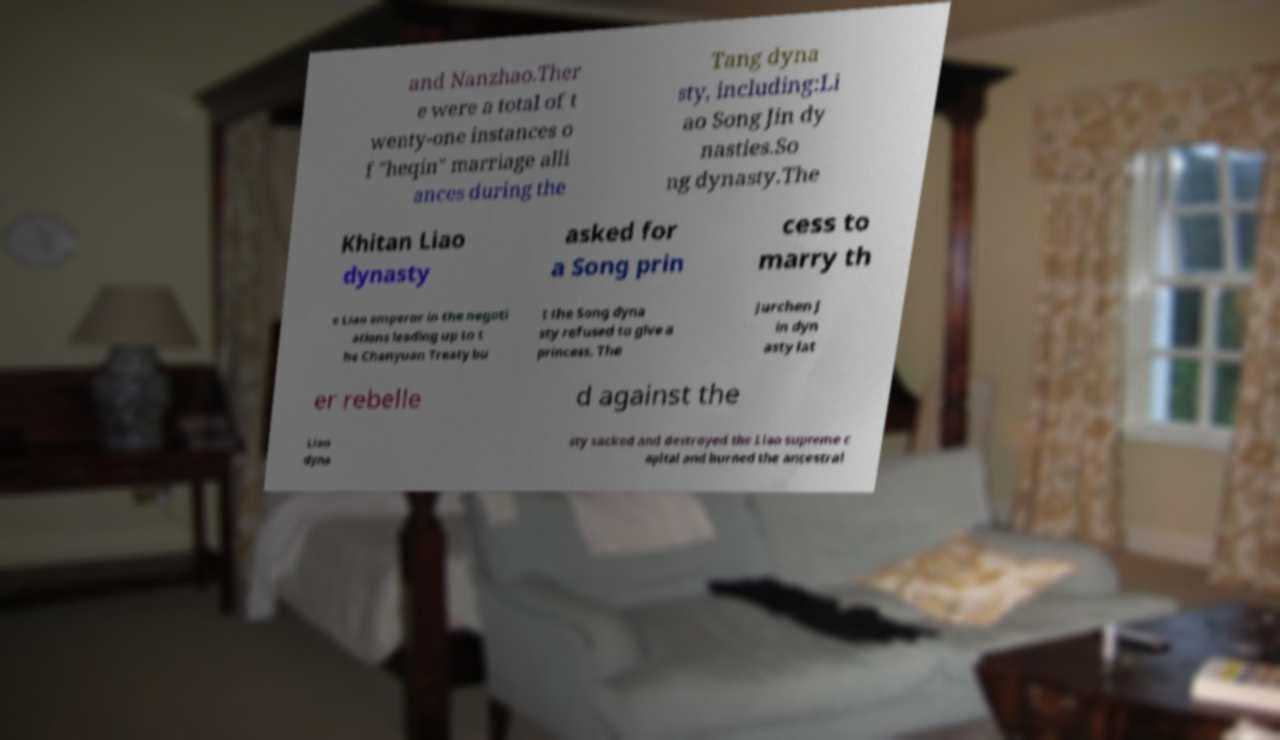Please identify and transcribe the text found in this image. and Nanzhao.Ther e were a total of t wenty-one instances o f "heqin" marriage alli ances during the Tang dyna sty, including:Li ao Song Jin dy nasties.So ng dynasty.The Khitan Liao dynasty asked for a Song prin cess to marry th e Liao emperor in the negoti ations leading up to t he Chanyuan Treaty bu t the Song dyna sty refused to give a princess. The Jurchen J in dyn asty lat er rebelle d against the Liao dyna sty sacked and destroyed the Liao supreme c apital and burned the ancestral 